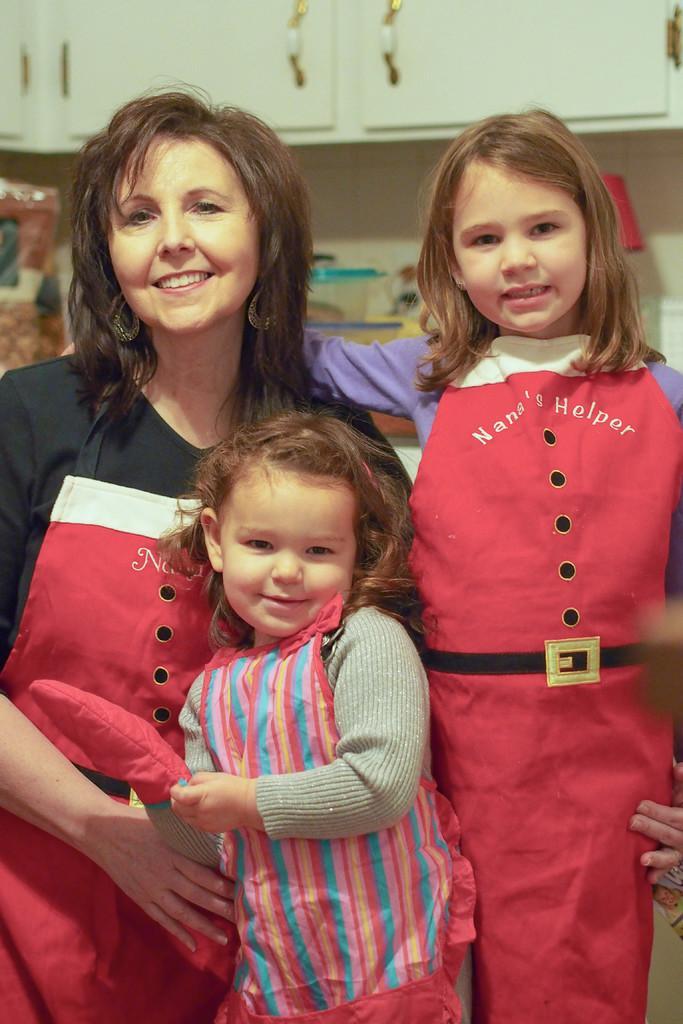Can you describe this image briefly? In this image in the center there are persons standing and smiling. In the background there are wardrobes which are white in colour and there is an object which is blue and white in colour, red colour lamp. 